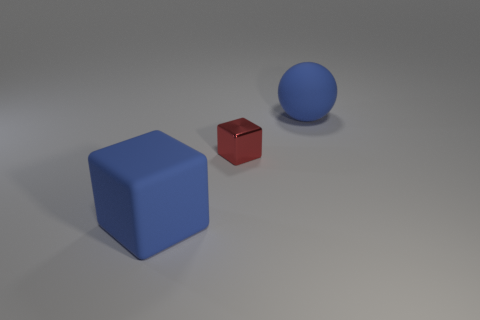Add 3 balls. How many objects exist? 6 Subtract all cubes. How many objects are left? 1 Add 3 red metallic cubes. How many red metallic cubes are left? 4 Add 3 blue matte things. How many blue matte things exist? 5 Subtract 0 yellow balls. How many objects are left? 3 Subtract all large objects. Subtract all large cyan rubber objects. How many objects are left? 1 